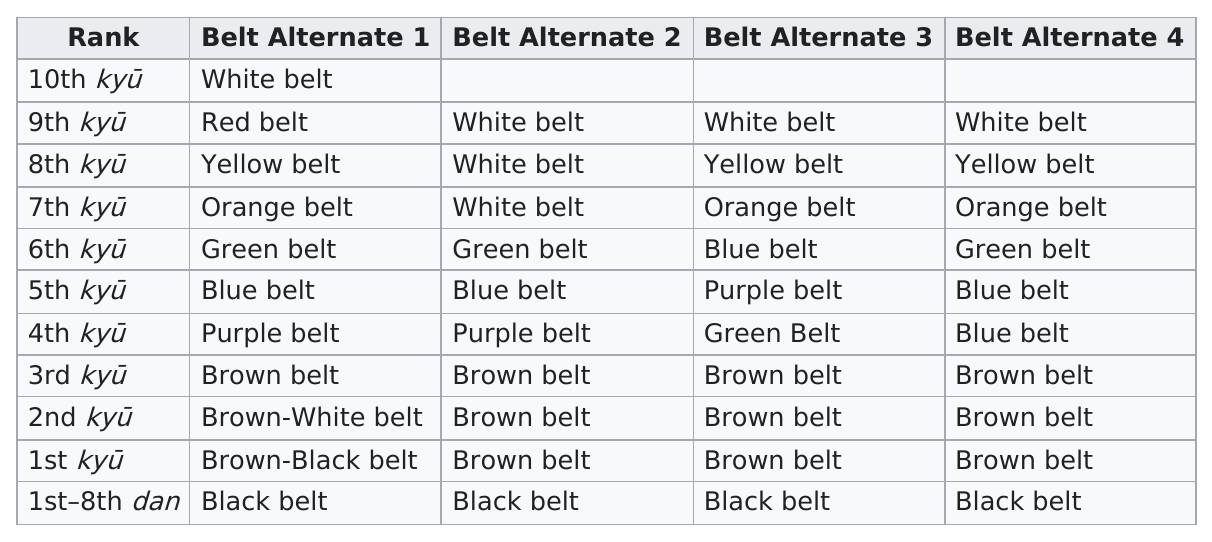Highlight a few significant elements in this photo. No, a 9th kyu practitioner cannot have a red belt and a black belt. Except for the first rank, there are three alternates for each subsequent rank. There are a total of 11 different colored belts available. After completing the 10th kyu, a practitioner would receive the white belt as their next rank. It is the case that only one color belt is used for students in the 10th kyu level of a certain martial arts ranking system. 